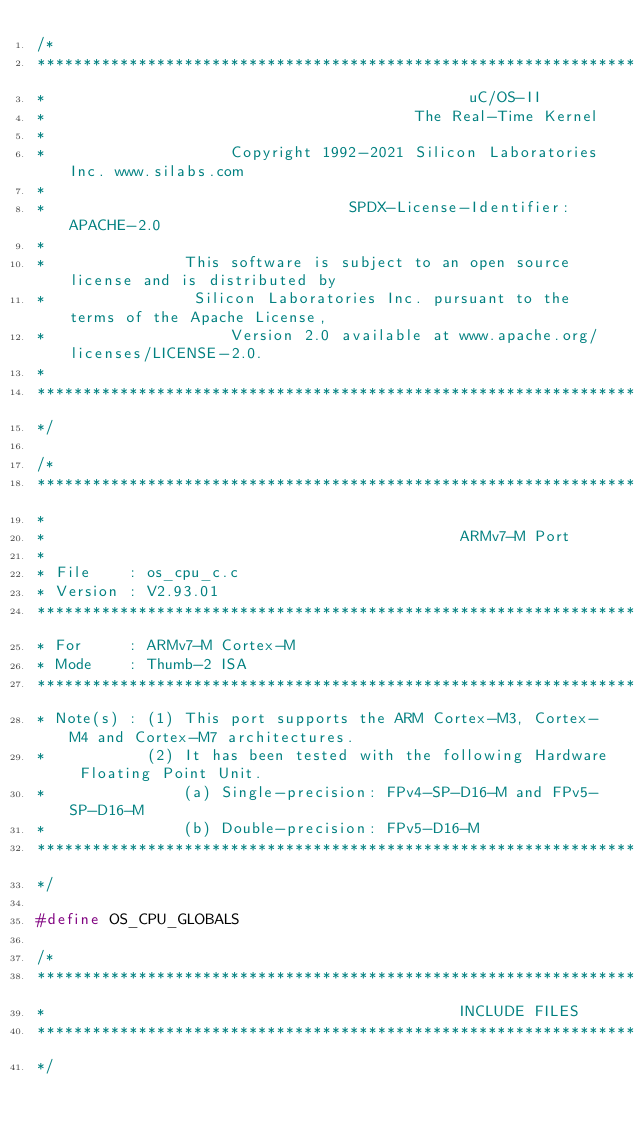Convert code to text. <code><loc_0><loc_0><loc_500><loc_500><_C_>/*
*********************************************************************************************************
*                                              uC/OS-II
*                                        The Real-Time Kernel
*
*                    Copyright 1992-2021 Silicon Laboratories Inc. www.silabs.com
*
*                                 SPDX-License-Identifier: APACHE-2.0
*
*               This software is subject to an open source license and is distributed by
*                Silicon Laboratories Inc. pursuant to the terms of the Apache License,
*                    Version 2.0 available at www.apache.org/licenses/LICENSE-2.0.
*
*********************************************************************************************************
*/

/*
*********************************************************************************************************
*
*                                             ARMv7-M Port
*
* File    : os_cpu_c.c
* Version : V2.93.01
*********************************************************************************************************
* For     : ARMv7-M Cortex-M
* Mode    : Thumb-2 ISA
*********************************************************************************************************
* Note(s) : (1) This port supports the ARM Cortex-M3, Cortex-M4 and Cortex-M7 architectures.
*           (2) It has been tested with the following Hardware Floating Point Unit.
*               (a) Single-precision: FPv4-SP-D16-M and FPv5-SP-D16-M
*               (b) Double-precision: FPv5-D16-M
*********************************************************************************************************
*/

#define OS_CPU_GLOBALS

/*
*********************************************************************************************************
*                                             INCLUDE FILES
*********************************************************************************************************
*/
</code> 